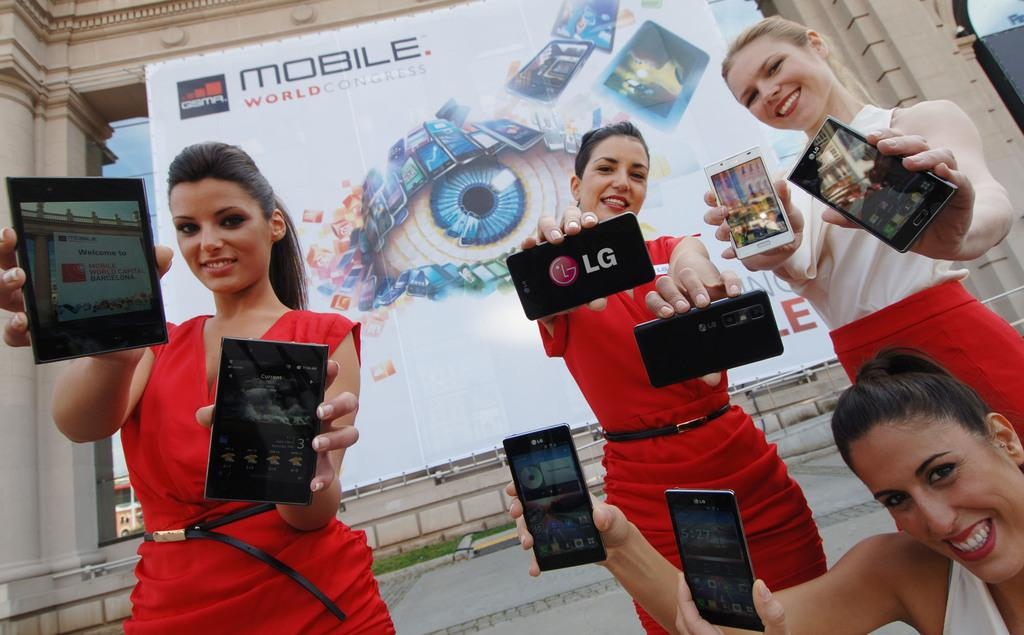How many women are present in the image? There are four women in the image. What are the women holding in their hands? Each woman is holding a mobile in her hand. Where is the image taken? The image is an outside view. What can be seen in the background of the image? There is a building in the background of the image. What is attached to the wall of the building? A board is attached to the wall of the building. What type of salt is being used by the women in the image? There is no salt present in the image; the women are holding mobiles. What type of underwear is the creator of the image wearing? The creator of the image is not present in the image, and therefore we cannot determine what type of underwear they might be wearing. 